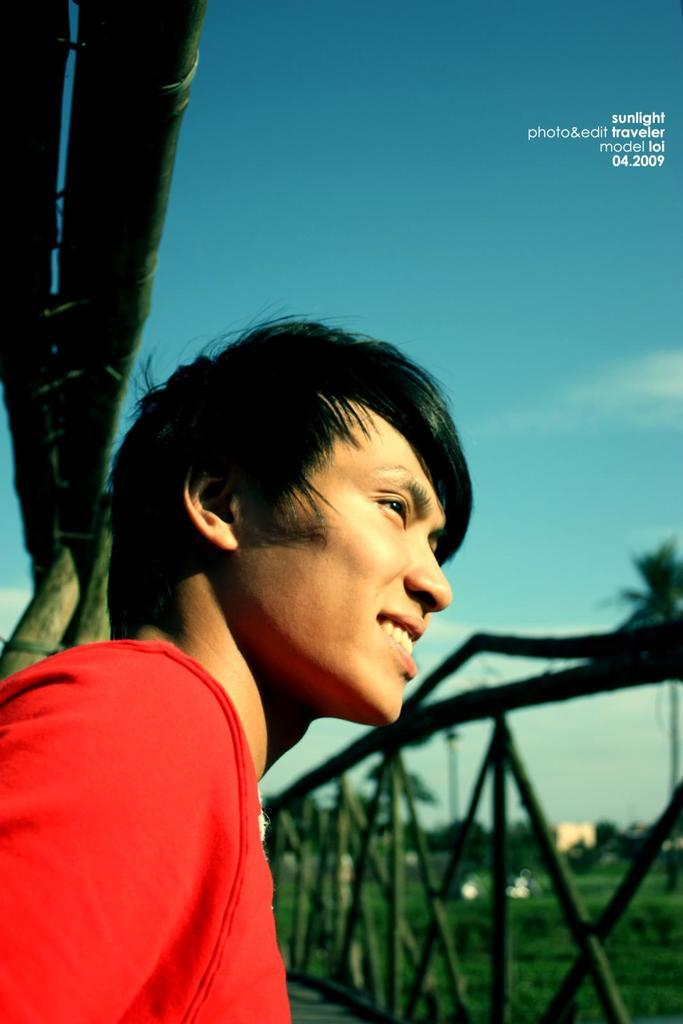Who is the main subject in the image? There is a man in the center of the image. What is the man doing in the image? The man is smiling. What can be seen on the right side of the image? There is a fence on the right side of the image. What is visible in the background of the image? There are trees and the sky visible in the background of the image. What type of can is visible in the image? There is no can present in the image. What title does the man hold in the image? The image does not provide any information about the man's title or occupation. 